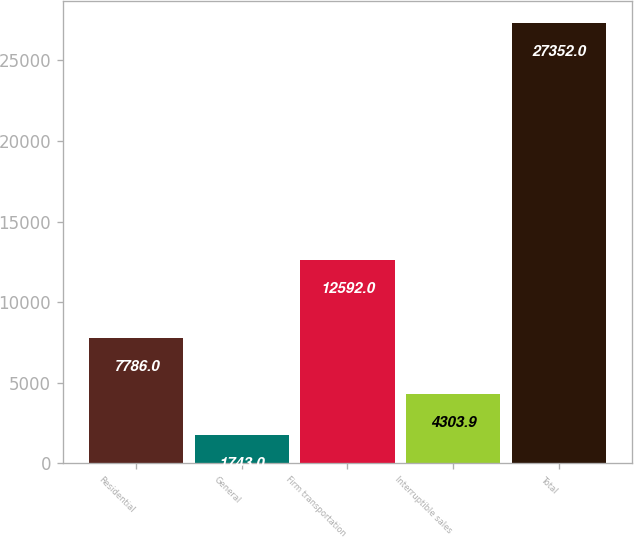Convert chart to OTSL. <chart><loc_0><loc_0><loc_500><loc_500><bar_chart><fcel>Residential<fcel>General<fcel>Firm transportation<fcel>Interruptible sales<fcel>Total<nl><fcel>7786<fcel>1743<fcel>12592<fcel>4303.9<fcel>27352<nl></chart> 